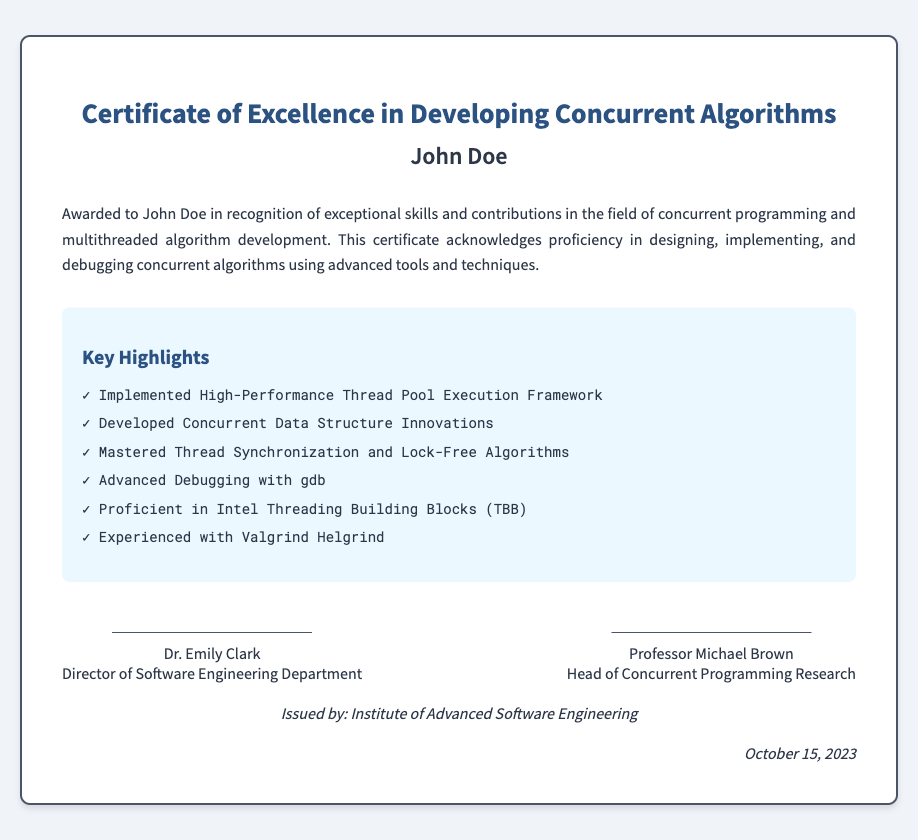what is the name of the recipient? The recipient is named in the document as John Doe.
Answer: John Doe who issued the certificate? The issuing organization is stated as the Institute of Advanced Software Engineering.
Answer: Institute of Advanced Software Engineering when was the certificate issued? The issuance date is found in the document, which states it as October 15, 2023.
Answer: October 15, 2023 what title does Dr. Emily Clark hold? The title of Dr. Emily Clark is specified as Director of Software Engineering Department.
Answer: Director of Software Engineering Department which programming concepts does this certificate highlight? The highlights include details on concurrent programming and multithreaded algorithm development, showcasing various skills and accomplishments of the recipient.
Answer: Concurrent programming and multithreaded algorithm development what is one of the key highlights mentioned? The document lists several key highlights, one of which can be "Advanced Debugging with gdb."
Answer: Advanced Debugging with gdb who is the head of the Concurrent Programming Research? The document identifies Professor Michael Brown as the head of this research area.
Answer: Professor Michael Brown how many key highlights are listed in the document? There are six key highlights listed in the section provided in the document.
Answer: Six 